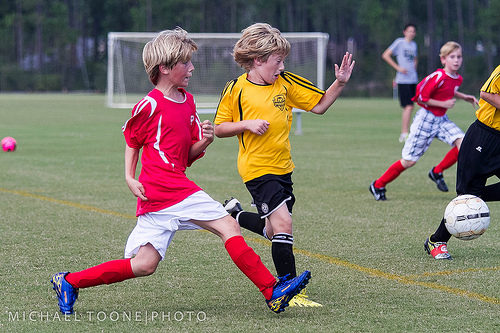<image>
Is the shoe on the boy? No. The shoe is not positioned on the boy. They may be near each other, but the shoe is not supported by or resting on top of the boy. Is there a boy next to the ball? No. The boy is not positioned next to the ball. They are located in different areas of the scene. Where is the soccer ball in relation to the field? Is it above the field? Yes. The soccer ball is positioned above the field in the vertical space, higher up in the scene. 